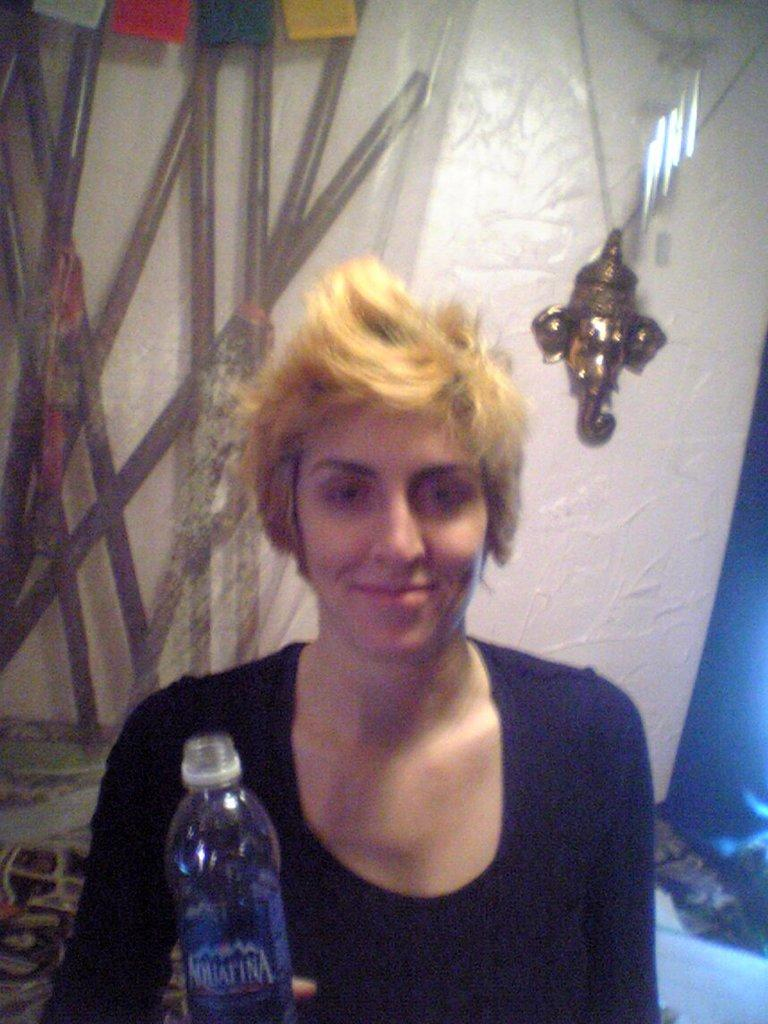Who is present in the image? There is a woman in the image. What is the woman doing in the image? The woman is sitting and smiling. What is the woman holding in her hand? The woman is holding a bottle in her hand. What can be seen in the background of the image? There is a wall in the background of the image. How does the woman's muscle strength contribute to the image? The image does not provide any information about the woman's muscle strength, so it cannot be determined how it contributes to the image. 